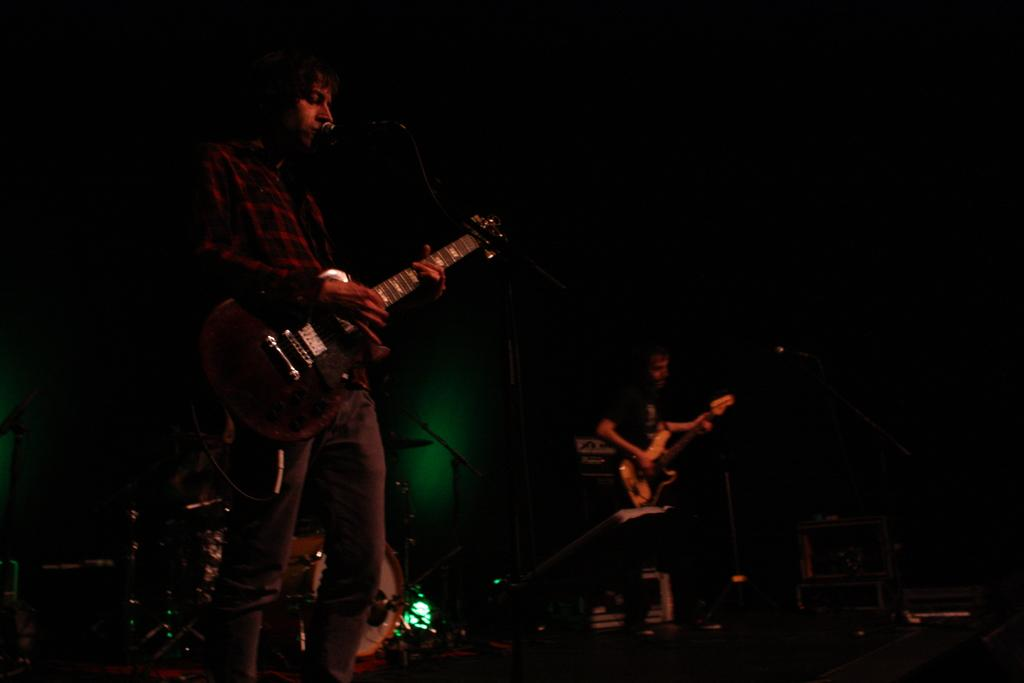What is the main subject of the image? The main subject of the image is a man. Where is the man positioned in the image? The man is standing on the left side of the image. What is the man doing in the image? The man is singing and holding a music instrument. What is the man using to amplify his voice? The man is using a microphone. What is the color of the microphone? The microphone is black in color. How many horses can be seen in the image? There are no horses present in the image. What type of stitch is the man using to sew a piece of clothing in the image? There is no sewing or piece of clothing present in the image; the man is singing and holding a music instrument. 